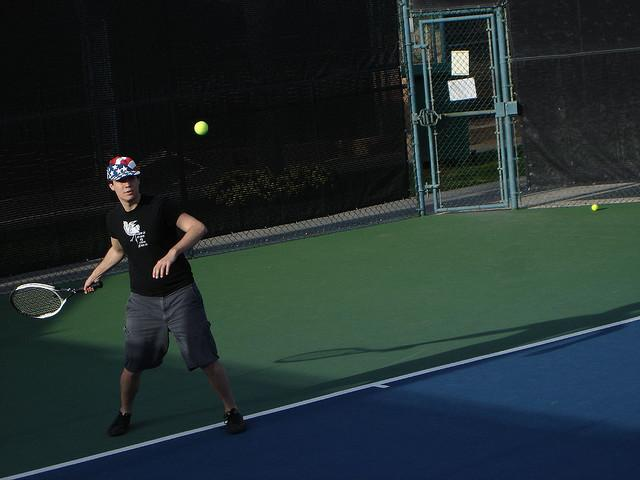Why is their hand held way back? forehand 